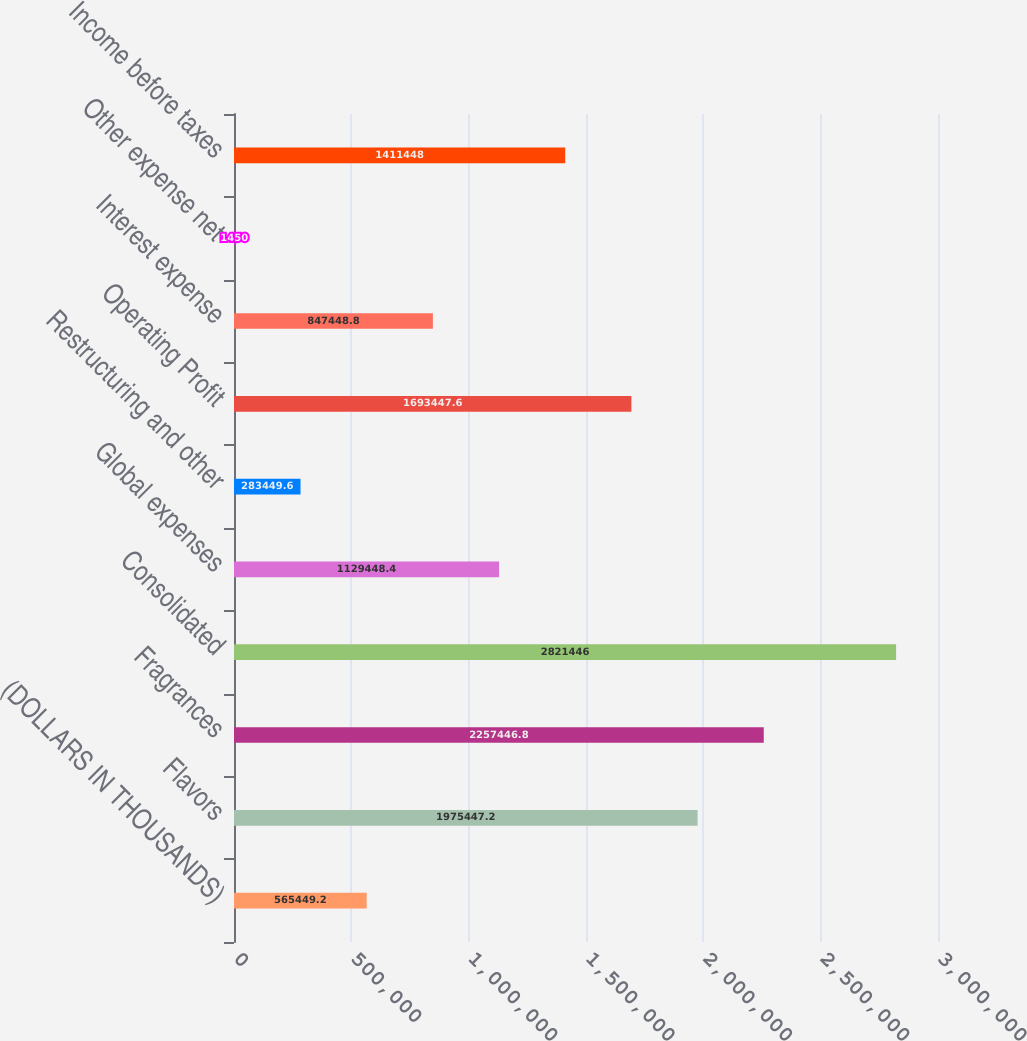<chart> <loc_0><loc_0><loc_500><loc_500><bar_chart><fcel>(DOLLARS IN THOUSANDS)<fcel>Flavors<fcel>Fragrances<fcel>Consolidated<fcel>Global expenses<fcel>Restructuring and other<fcel>Operating Profit<fcel>Interest expense<fcel>Other expense net<fcel>Income before taxes<nl><fcel>565449<fcel>1.97545e+06<fcel>2.25745e+06<fcel>2.82145e+06<fcel>1.12945e+06<fcel>283450<fcel>1.69345e+06<fcel>847449<fcel>1450<fcel>1.41145e+06<nl></chart> 